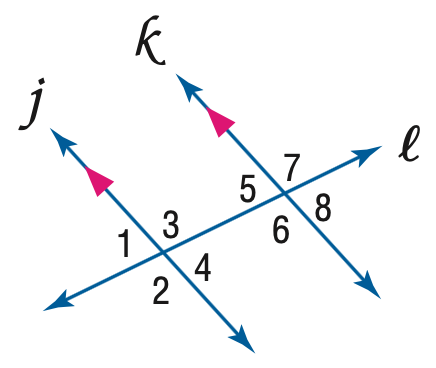Answer the mathemtical geometry problem and directly provide the correct option letter.
Question: Find y if m \angle 5 = 68 and m \angle 3 = 3 y - 2.
Choices: A: 22 B: 23.3 C: 38 D: 82 C 